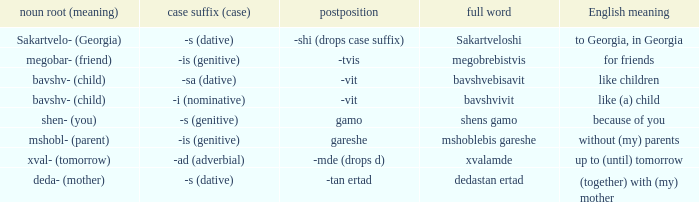Give me the full table as a dictionary. {'header': ['noun root (meaning)', 'case suffix (case)', 'postposition', 'full word', 'English meaning'], 'rows': [['Sakartvelo- (Georgia)', '-s (dative)', '-shi (drops case suffix)', 'Sakartveloshi', 'to Georgia, in Georgia'], ['megobar- (friend)', '-is (genitive)', '-tvis', 'megobrebistvis', 'for friends'], ['bavshv- (child)', '-sa (dative)', '-vit', 'bavshvebisavit', 'like children'], ['bavshv- (child)', '-i (nominative)', '-vit', 'bavshvivit', 'like (a) child'], ['shen- (you)', '-s (genitive)', 'gamo', 'shens gamo', 'because of you'], ['mshobl- (parent)', '-is (genitive)', 'gareshe', 'mshoblebis gareshe', 'without (my) parents'], ['xval- (tomorrow)', '-ad (adverbial)', '-mde (drops d)', 'xvalamde', 'up to (until) tomorrow'], ['deda- (mother)', '-s (dative)', '-tan ertad', 'dedastan ertad', '(together) with (my) mother']]} What is the Full Word, when Case Suffix (case) is "-sa (dative)"? Bavshvebisavit. 